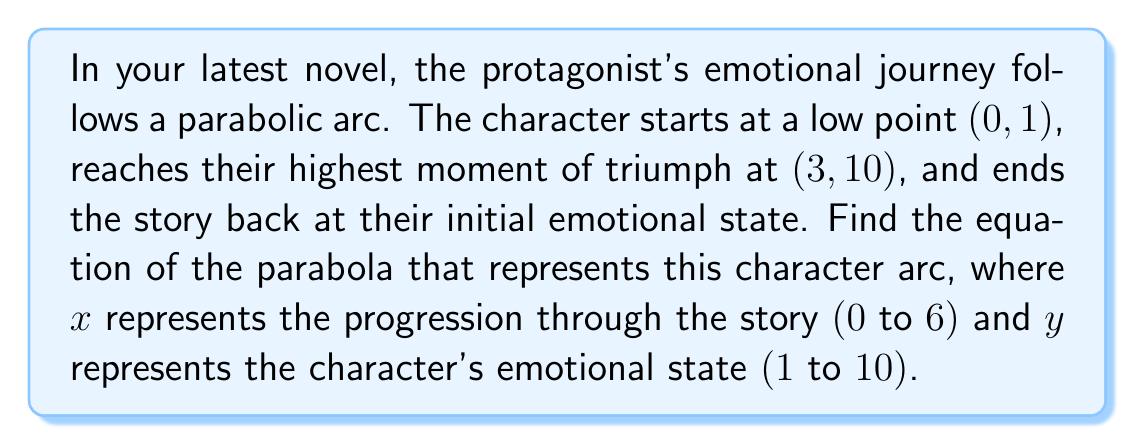Provide a solution to this math problem. Let's approach this step-by-step:

1) The general form of a parabola is $y = a(x-h)^2 + k$, where (h, k) is the vertex.

2) We know the vertex is (3, 10), so h = 3 and k = 10.

3) Our equation now looks like: $y = a(x-3)^2 + 10$

4) We need to find the value of a. We can use the point (0, 1) to do this:

   $1 = a(0-3)^2 + 10$
   $1 = 9a + 10$
   $-9 = 9a$
   $a = -1$

5) Therefore, our parabola equation is:

   $y = -(x-3)^2 + 10$

6) To verify, let's check if it passes through (6, 1):

   $y = -(6-3)^2 + 10 = -9 + 10 = 1$

   It does, confirming our equation.
Answer: $y = -(x-3)^2 + 10$ 